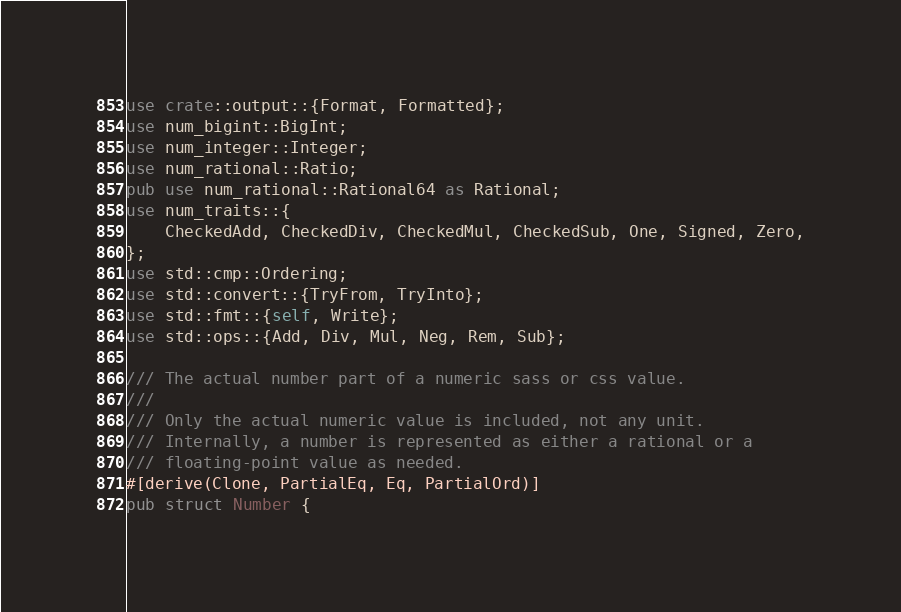Convert code to text. <code><loc_0><loc_0><loc_500><loc_500><_Rust_>use crate::output::{Format, Formatted};
use num_bigint::BigInt;
use num_integer::Integer;
use num_rational::Ratio;
pub use num_rational::Rational64 as Rational;
use num_traits::{
    CheckedAdd, CheckedDiv, CheckedMul, CheckedSub, One, Signed, Zero,
};
use std::cmp::Ordering;
use std::convert::{TryFrom, TryInto};
use std::fmt::{self, Write};
use std::ops::{Add, Div, Mul, Neg, Rem, Sub};

/// The actual number part of a numeric sass or css value.
///
/// Only the actual numeric value is included, not any unit.
/// Internally, a number is represented as either a rational or a
/// floating-point value as needed.
#[derive(Clone, PartialEq, Eq, PartialOrd)]
pub struct Number {</code> 